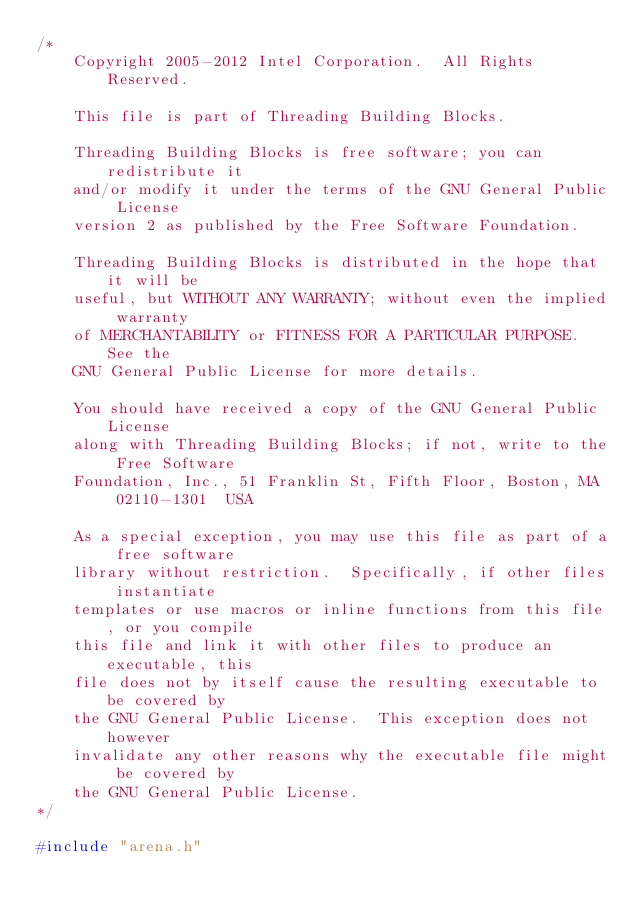Convert code to text. <code><loc_0><loc_0><loc_500><loc_500><_C++_>/*
    Copyright 2005-2012 Intel Corporation.  All Rights Reserved.

    This file is part of Threading Building Blocks.

    Threading Building Blocks is free software; you can redistribute it
    and/or modify it under the terms of the GNU General Public License
    version 2 as published by the Free Software Foundation.

    Threading Building Blocks is distributed in the hope that it will be
    useful, but WITHOUT ANY WARRANTY; without even the implied warranty
    of MERCHANTABILITY or FITNESS FOR A PARTICULAR PURPOSE.  See the
    GNU General Public License for more details.

    You should have received a copy of the GNU General Public License
    along with Threading Building Blocks; if not, write to the Free Software
    Foundation, Inc., 51 Franklin St, Fifth Floor, Boston, MA  02110-1301  USA

    As a special exception, you may use this file as part of a free software
    library without restriction.  Specifically, if other files instantiate
    templates or use macros or inline functions from this file, or you compile
    this file and link it with other files to produce an executable, this
    file does not by itself cause the resulting executable to be covered by
    the GNU General Public License.  This exception does not however
    invalidate any other reasons why the executable file might be covered by
    the GNU General Public License.
*/

#include "arena.h"</code> 